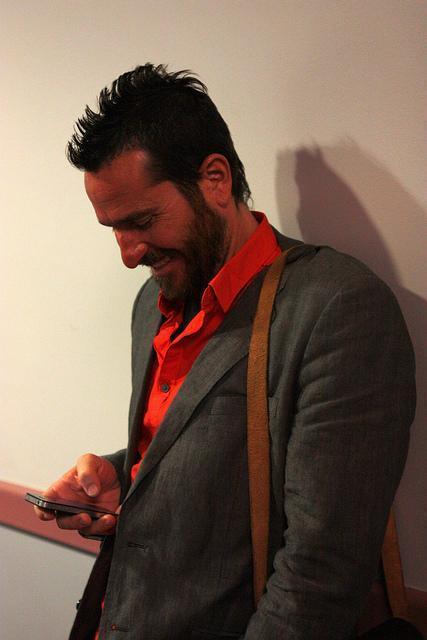How many handbags are there?
Give a very brief answer. 1. How many horses are there?
Give a very brief answer. 0. 